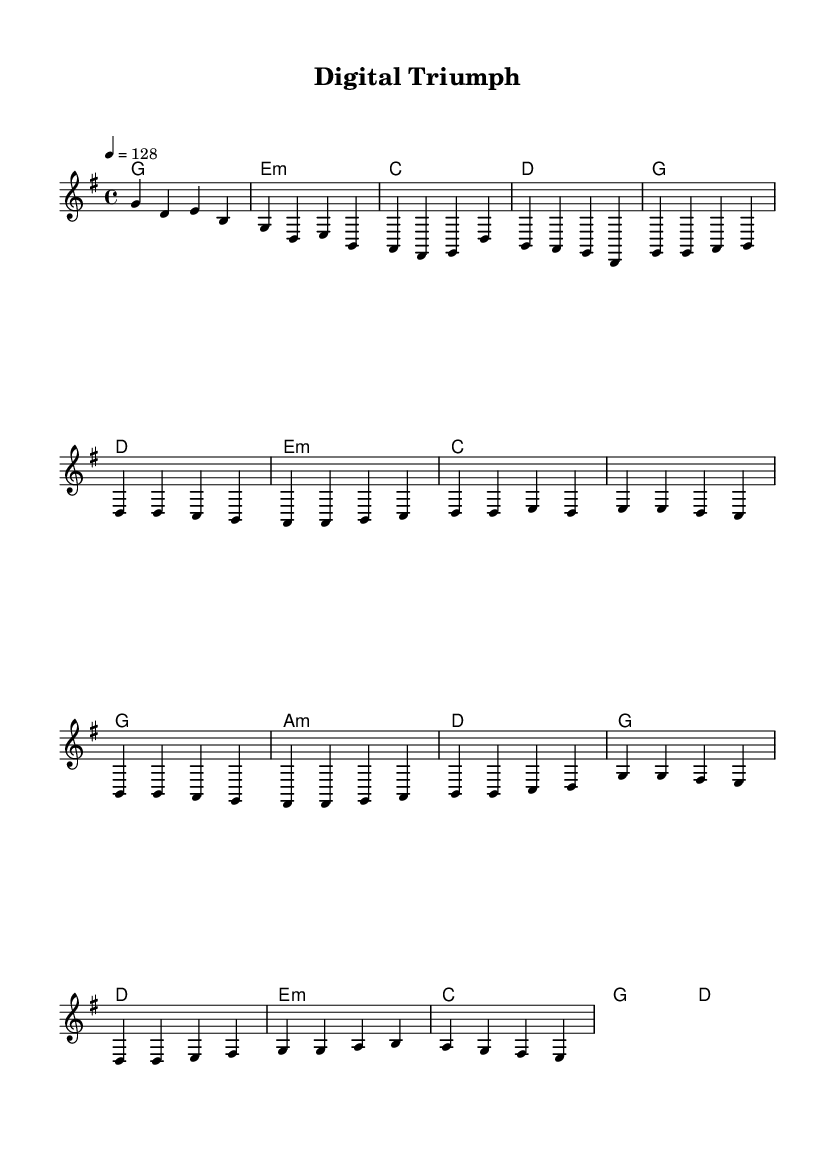What is the key signature of this music? The key signature is G major, which has one sharp (F#).
Answer: G major What is the time signature of this piece? The time signature is 4/4, indicating that there are four beats in each measure and the quarter note gets one beat.
Answer: 4/4 What is the tempo marking for this piece? The tempo marking is 128 beats per minute, indicating a lively and fast-paced feel suitable for an upbeat song.
Answer: 128 What is the first chord in the introduction? The first chord in the introduction is G major, as indicated by the chord written above the staff at the start.
Answer: G major In which section does the melody primarily move upward? The chorus features upward melodic movement, with the melody ascending to higher notes, particularly noticeable in the transition from G to A.
Answer: Chorus How many bars are in the verse section? The verse section contains eight bars, as indicated by the measures marked under the verse line.
Answer: 8 What type of harmony is featured in the pre-chorus? The pre-chorus employs a mix of major and minor harmonies, specifically using C major, G major, A minor, and D major in a progression.
Answer: Mix of major and minor 